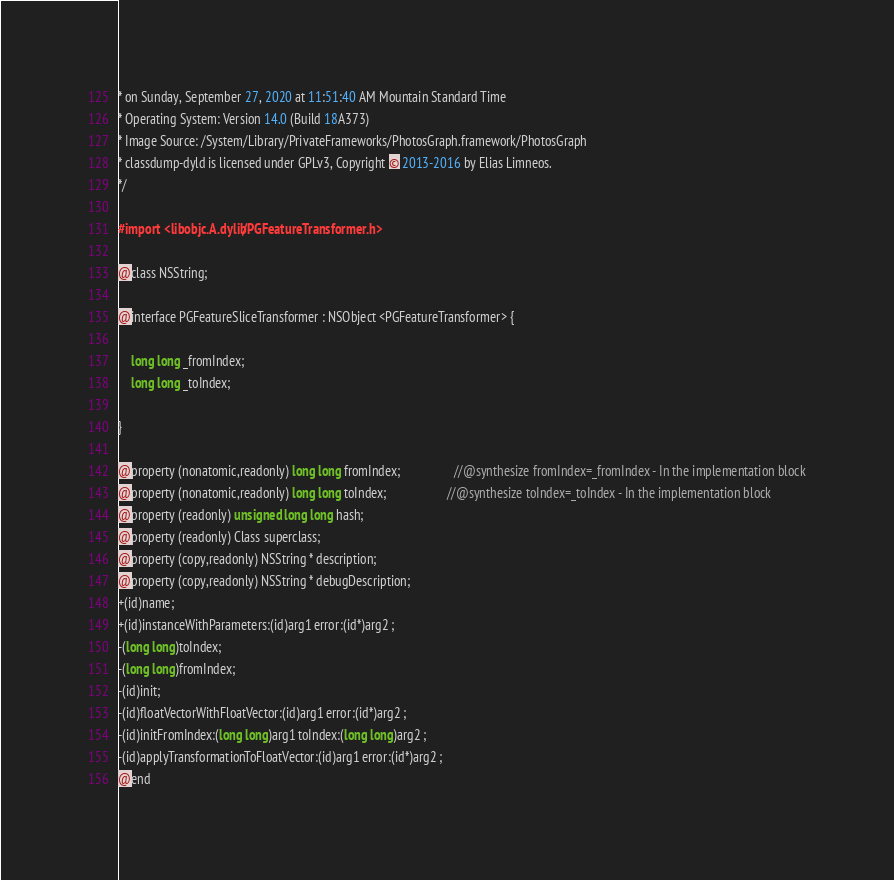Convert code to text. <code><loc_0><loc_0><loc_500><loc_500><_C_>* on Sunday, September 27, 2020 at 11:51:40 AM Mountain Standard Time
* Operating System: Version 14.0 (Build 18A373)
* Image Source: /System/Library/PrivateFrameworks/PhotosGraph.framework/PhotosGraph
* classdump-dyld is licensed under GPLv3, Copyright © 2013-2016 by Elias Limneos.
*/

#import <libobjc.A.dylib/PGFeatureTransformer.h>

@class NSString;

@interface PGFeatureSliceTransformer : NSObject <PGFeatureTransformer> {

	long long _fromIndex;
	long long _toIndex;

}

@property (nonatomic,readonly) long long fromIndex;                 //@synthesize fromIndex=_fromIndex - In the implementation block
@property (nonatomic,readonly) long long toIndex;                   //@synthesize toIndex=_toIndex - In the implementation block
@property (readonly) unsigned long long hash; 
@property (readonly) Class superclass; 
@property (copy,readonly) NSString * description; 
@property (copy,readonly) NSString * debugDescription; 
+(id)name;
+(id)instanceWithParameters:(id)arg1 error:(id*)arg2 ;
-(long long)toIndex;
-(long long)fromIndex;
-(id)init;
-(id)floatVectorWithFloatVector:(id)arg1 error:(id*)arg2 ;
-(id)initFromIndex:(long long)arg1 toIndex:(long long)arg2 ;
-(id)applyTransformationToFloatVector:(id)arg1 error:(id*)arg2 ;
@end

</code> 